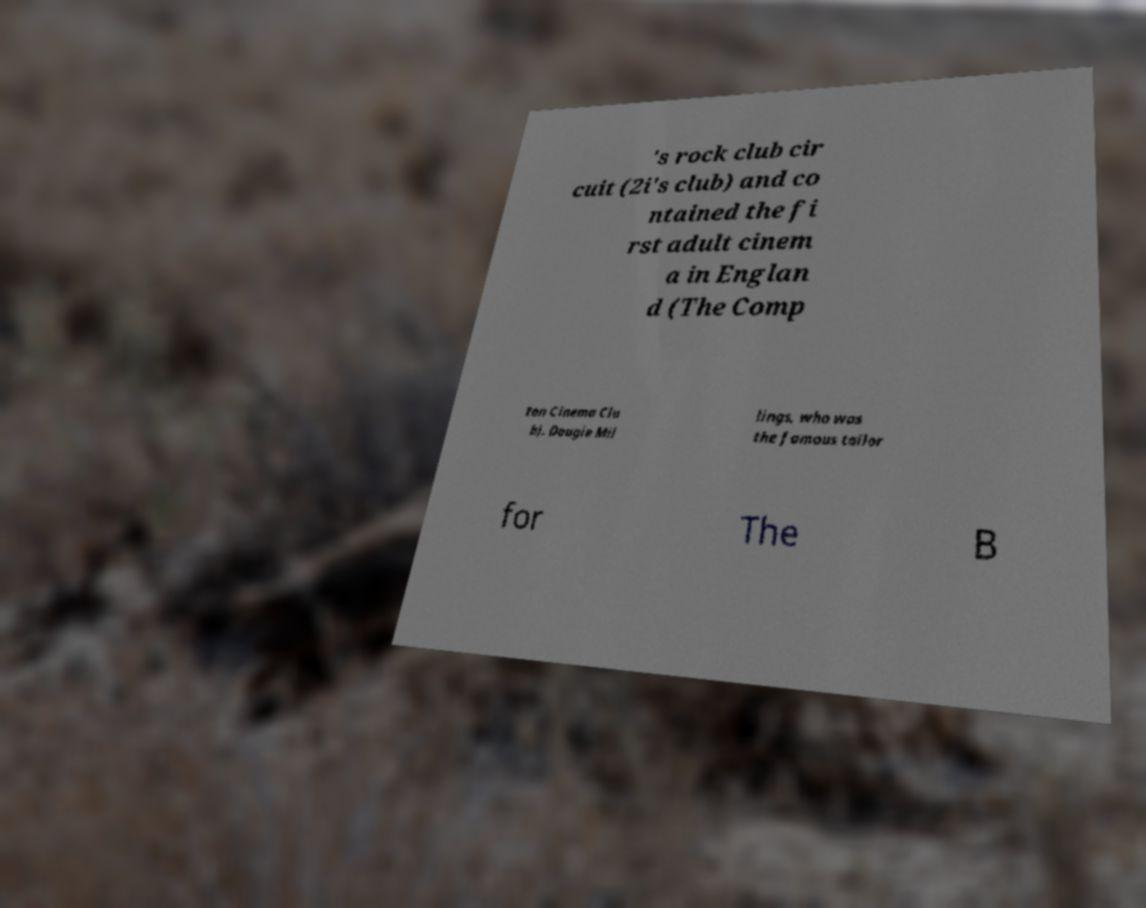Can you read and provide the text displayed in the image?This photo seems to have some interesting text. Can you extract and type it out for me? 's rock club cir cuit (2i's club) and co ntained the fi rst adult cinem a in Englan d (The Comp ton Cinema Clu b). Dougie Mil lings, who was the famous tailor for The B 